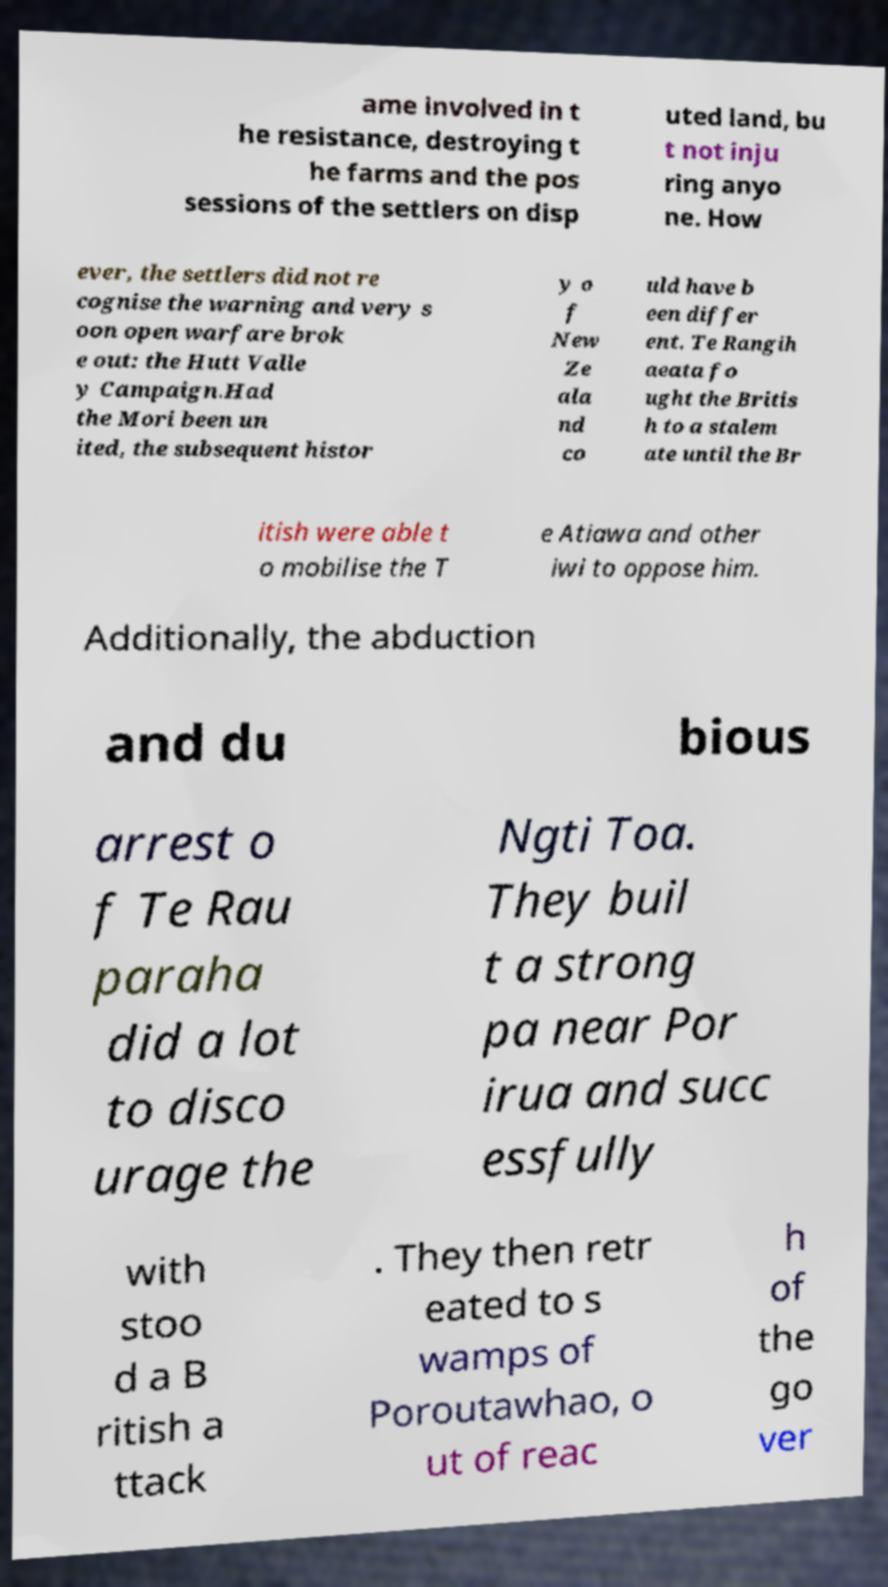What messages or text are displayed in this image? I need them in a readable, typed format. ame involved in t he resistance, destroying t he farms and the pos sessions of the settlers on disp uted land, bu t not inju ring anyo ne. How ever, the settlers did not re cognise the warning and very s oon open warfare brok e out: the Hutt Valle y Campaign.Had the Mori been un ited, the subsequent histor y o f New Ze ala nd co uld have b een differ ent. Te Rangih aeata fo ught the Britis h to a stalem ate until the Br itish were able t o mobilise the T e Atiawa and other iwi to oppose him. Additionally, the abduction and du bious arrest o f Te Rau paraha did a lot to disco urage the Ngti Toa. They buil t a strong pa near Por irua and succ essfully with stoo d a B ritish a ttack . They then retr eated to s wamps of Poroutawhao, o ut of reac h of the go ver 